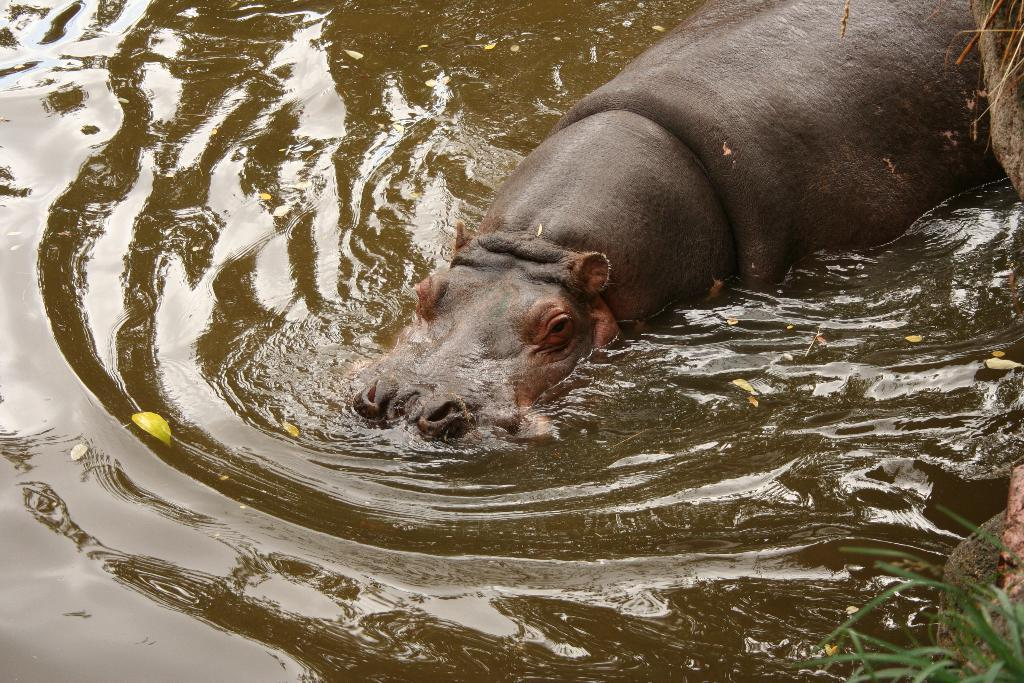What animal is in the image? There is a hippopotamus in the image. Where is the hippopotamus located? The hippopotamus is in the water. What can be seen in the background of the image? There is water visible in the image. What type of vegetation is present at the bottom right of the image? There is grass at the bottom right of the image. What type of picture is the hippopotamus attending in the image? There is no picture or meeting present in the image; it features a hippopotamus in the water. Can you tell me how many toad's role in the image? There is no toad present in the image. 